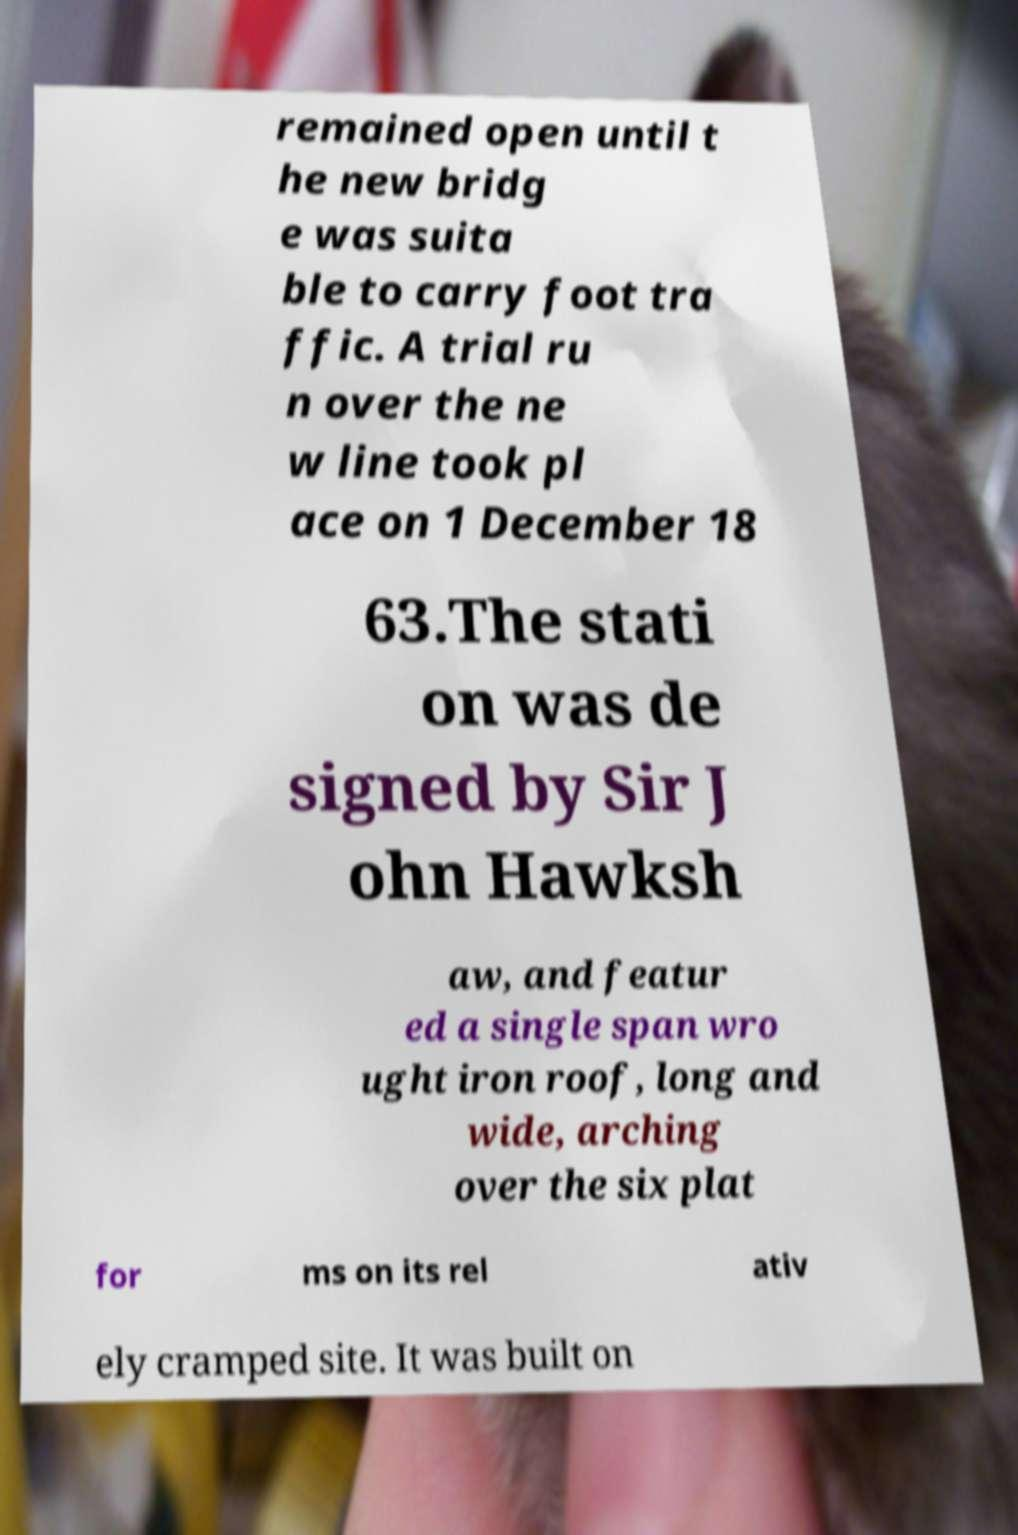What messages or text are displayed in this image? I need them in a readable, typed format. remained open until t he new bridg e was suita ble to carry foot tra ffic. A trial ru n over the ne w line took pl ace on 1 December 18 63.The stati on was de signed by Sir J ohn Hawksh aw, and featur ed a single span wro ught iron roof, long and wide, arching over the six plat for ms on its rel ativ ely cramped site. It was built on 